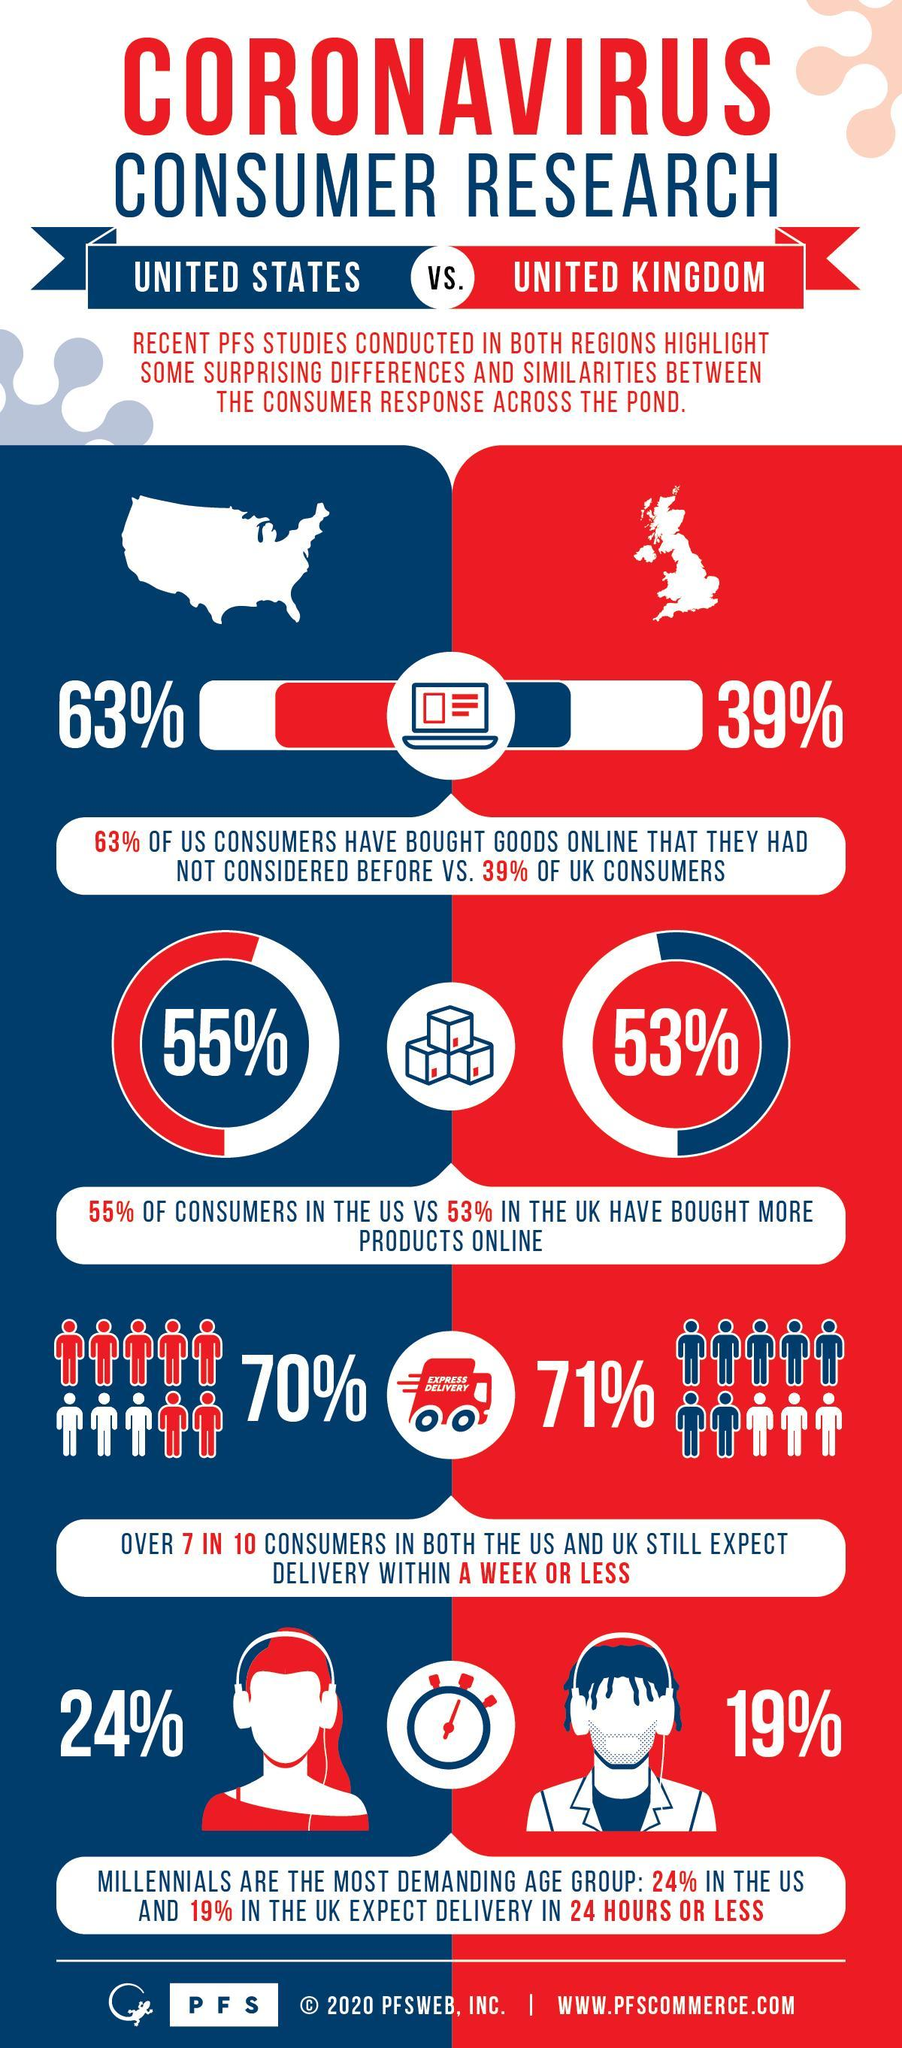What percentage of UK consumers still expect the delivery of their products within a week or less?
Answer the question with a short phrase. 71% What percentage of UK consumers have bought goods online that they had not considered before? 39% What percentage of US consumers still expect the delivery of their products within a week or less? 70% What percentage of US consumers have bought more products online? 55% 